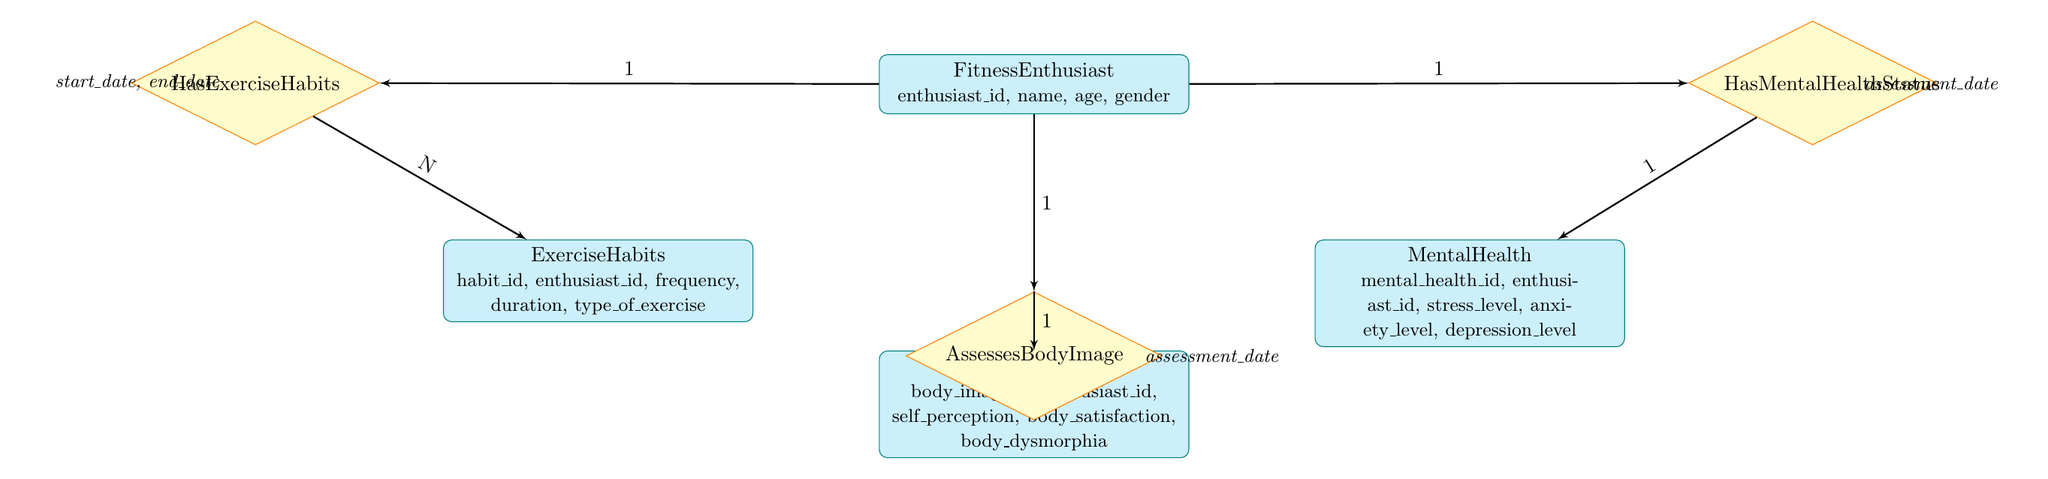What is the total number of entities in the diagram? The diagram lists four entities: FitnessEnthusiast, ExerciseHabits, MentalHealth, and BodyImage. Thus, we count them to find the total.
Answer: 4 What relationship connects FitnessEnthusiast and BodyImage? The diagram shows that FitnessEnthusiast is connected to BodyImage through the relationship called AssessesBodyImage. This can be confirmed by observing the lines connecting these nodes.
Answer: AssessesBodyImage How many attributes does MentalHealth have? The entity MentalHealth contains five attributes: mental_health_id, enthusiast_id, stress_level, anxiety_level, and depression_level. By counting, we identify the total number of attributes in this entity.
Answer: 5 What is the relationship type between ExerciseHabits and FitnessEnthusiast? The relationship between ExerciseHabits and FitnessEnthusiast is identified as HasExerciseHabits. We determine this by reviewing the relationships diagrammed between these two entities.
Answer: HasExerciseHabits Which entity has the attribute 'self_perception'? In the diagram, the attribute 'self_perception' is listed under the entity BodyImage. We can confirm this by looking directly at the attributes listed for that particular entity.
Answer: BodyImage What is the minimum number of relationships connected to FitnessEnthusiast? FitnessEnthusiast is involved in three distinct relationships: HasExerciseHabits, HasMentalHealthStatus, and AssessesBodyImage. By counting these relationships, we determine the minimum.
Answer: 3 Which entity is directly linked to MentalHealth? MentalHealth is directly linked to FitnessEnthusiast through the relationship HasMentalHealthStatus. Reviewing the connections and relationships helps identify this link.
Answer: FitnessEnthusiast What are the attributes of the relationship HasExerciseHabits? The attributes of the relationship HasExerciseHabits are start_date and end_date. By reviewing the text associated with this relationship in the diagram, we find the necessary information.
Answer: start_date, end_date How does self_satisfaction relate to BodyImage? BodyImage contains the attribute body_satisfaction, which indicates a direct relation to the broader concept of BodyImage. Reviewing the attributes for BodyImage confirms this relationship.
Answer: body_satisfaction 